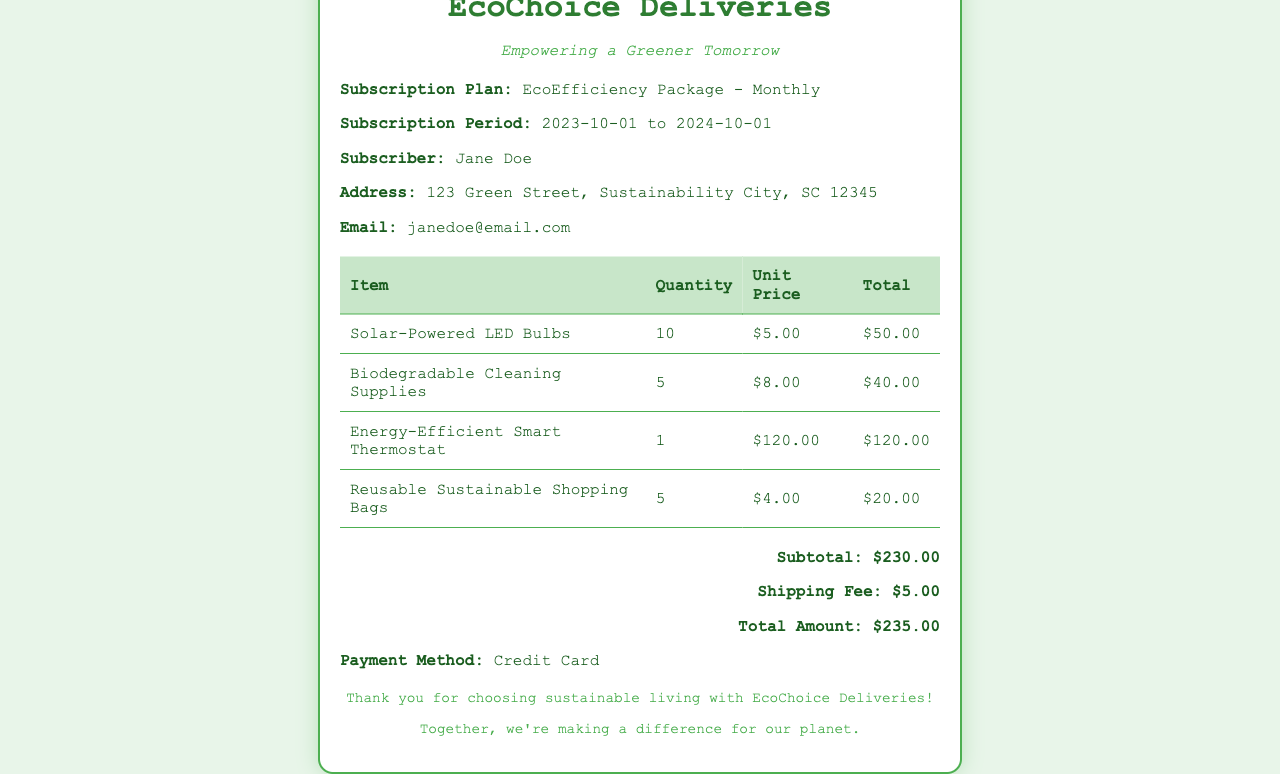what is the subscriber's name? The subscriber's name is clearly stated in the document under "Subscriber."
Answer: Jane Doe what is the subscription plan? The subscription plan is mentioned in the details section of the document.
Answer: EcoEfficiency Package - Monthly what is the total amount due? The total amount is provided at the bottom of the receipt in the total section.
Answer: $235.00 how many Solar-Powered LED Bulbs were ordered? The quantity ordered for Solar-Powered LED Bulbs is found in the itemized list.
Answer: 10 what is the shipping fee? The shipping fee is specified in the total section of the receipt.
Answer: $5.00 what is the purpose of this document? The document serves a specific function related to the delivery service.
Answer: Receipt what is the email address of the subscriber? The subscriber's email is provided in the details section.
Answer: janedoe@email.com what is the subscription period? The subscription period is detailed in the document's details section.
Answer: 2023-10-01 to 2024-10-01 how many items are listed in the order? The number of items can be counted from the itemized list, adding up the total entries.
Answer: 4 